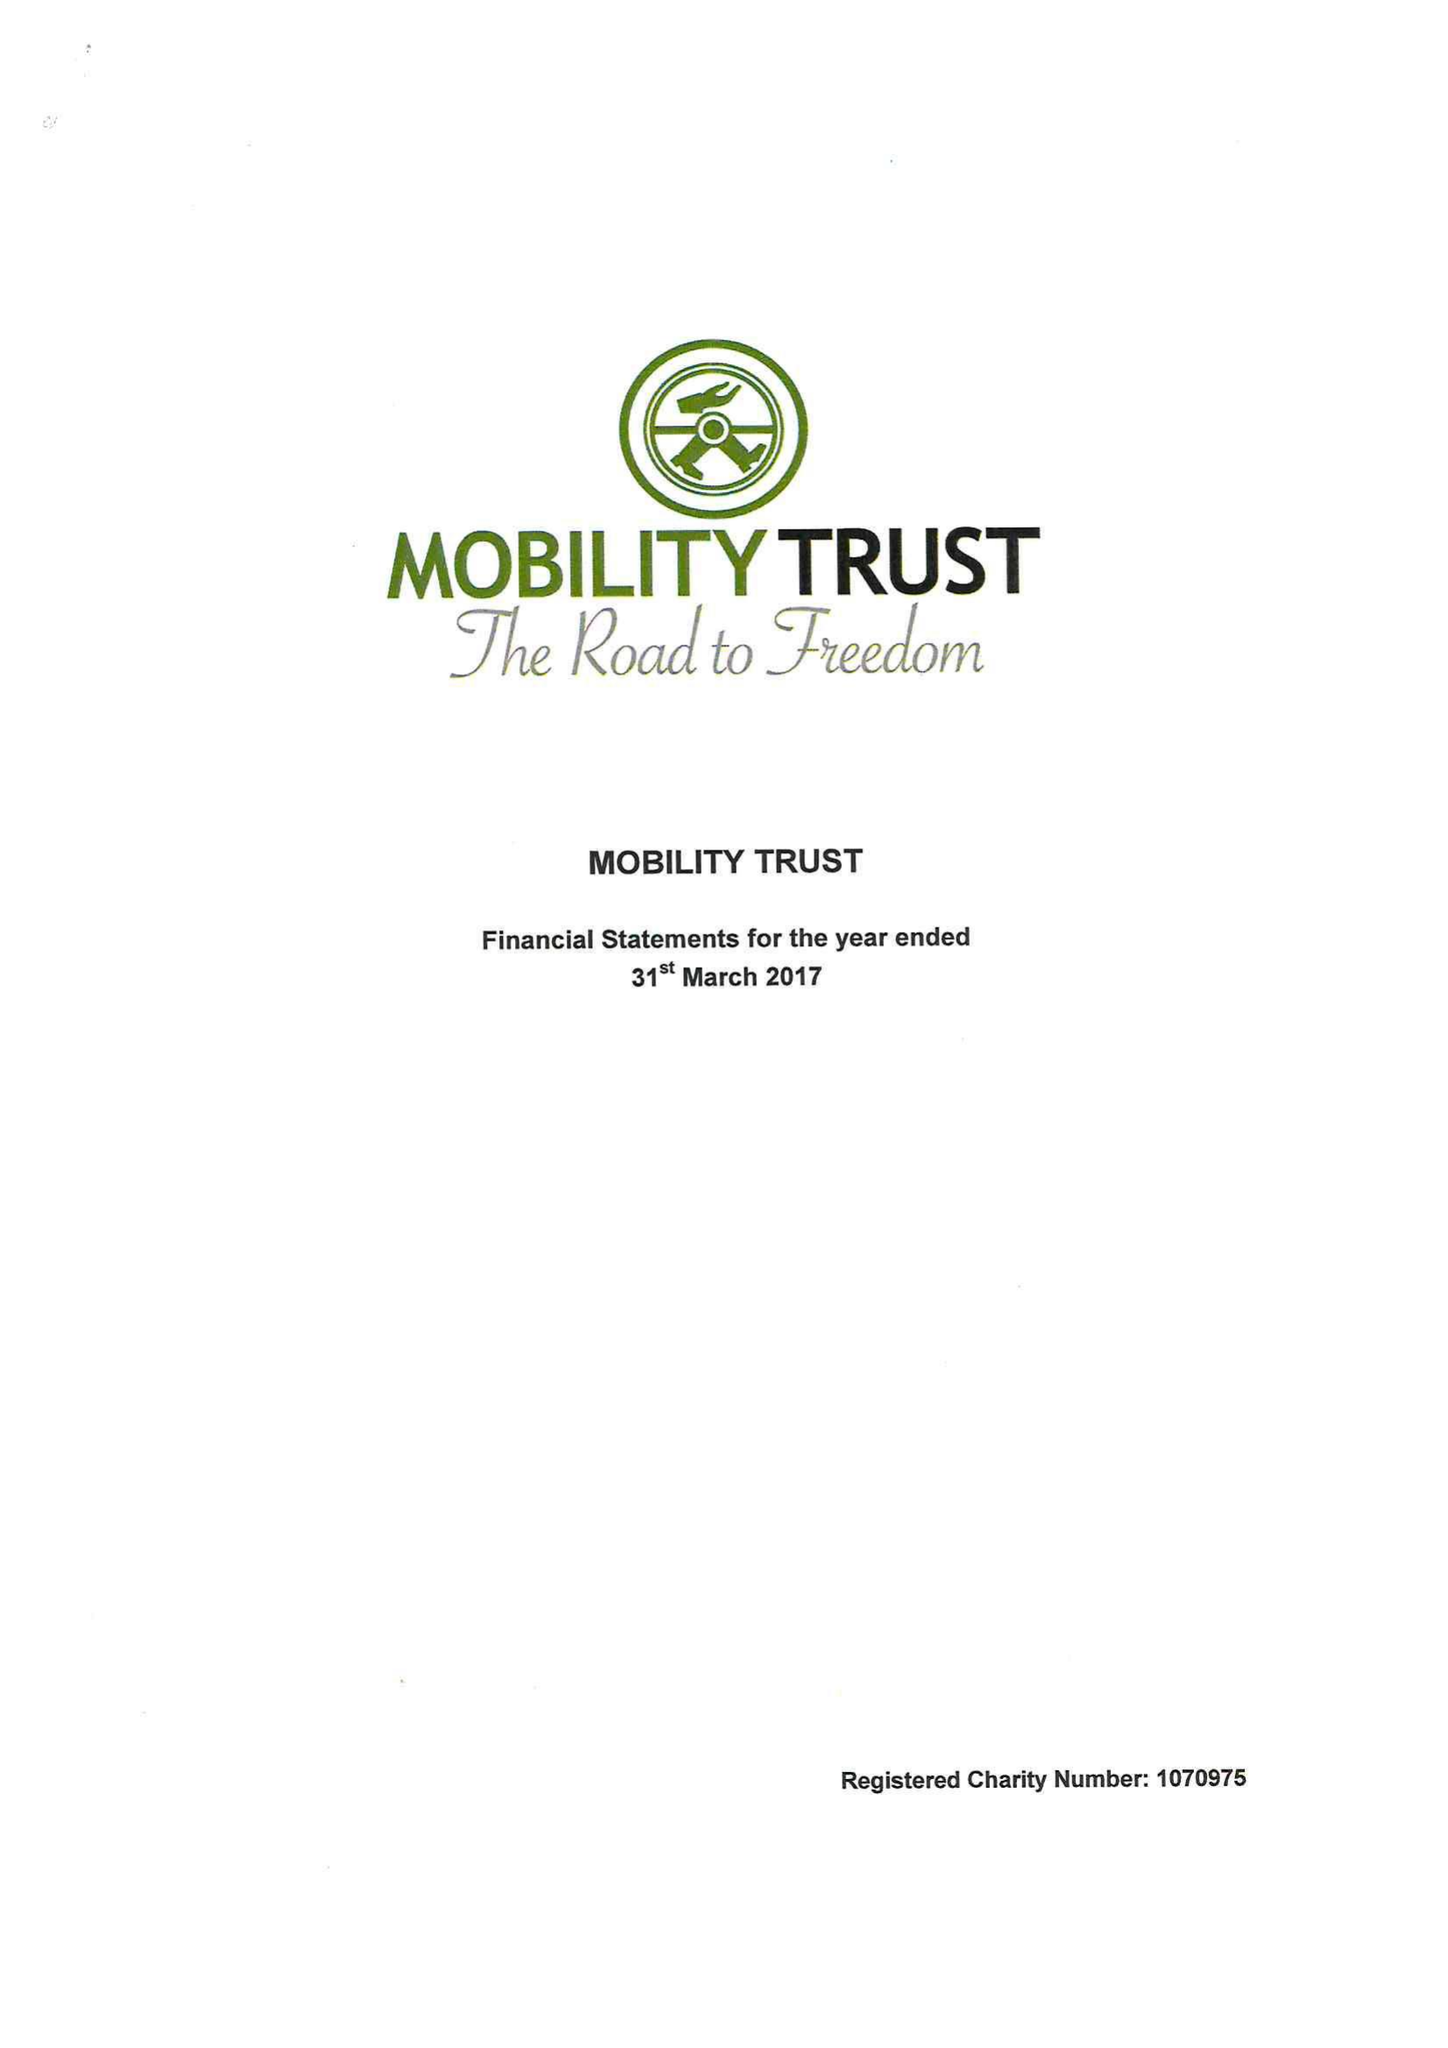What is the value for the report_date?
Answer the question using a single word or phrase. 2017-03-31 